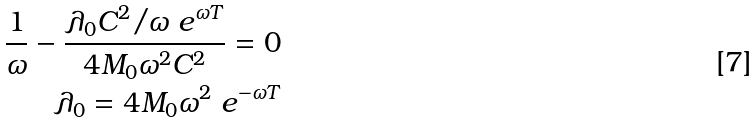<formula> <loc_0><loc_0><loc_500><loc_500>\frac { 1 } { \omega } - \frac { \lambda _ { 0 } C ^ { 2 } / \omega \ e ^ { \omega T } } { 4 M _ { 0 } \omega ^ { 2 } C ^ { 2 } } = 0 \\ \lambda _ { 0 } = 4 M _ { 0 } \omega ^ { 2 } \ e ^ { - \omega T }</formula> 